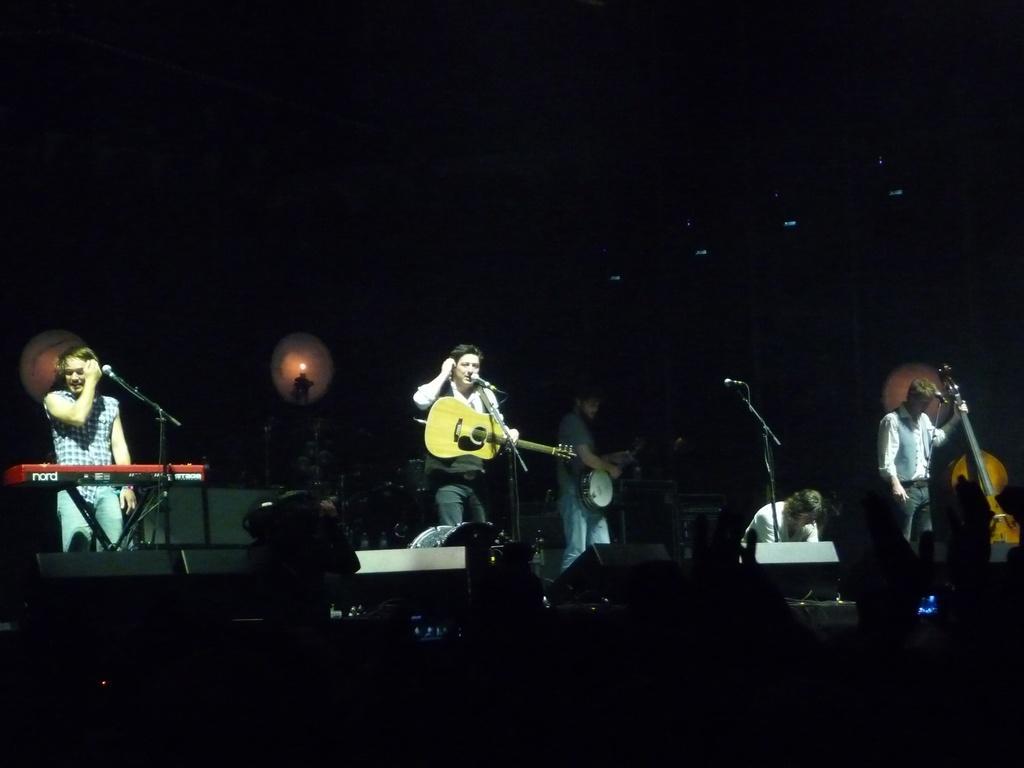Please provide a concise description of this image. In the image there are people who are standing and they are holding guitar in their hand and a person over here is standing in front of a casio. 